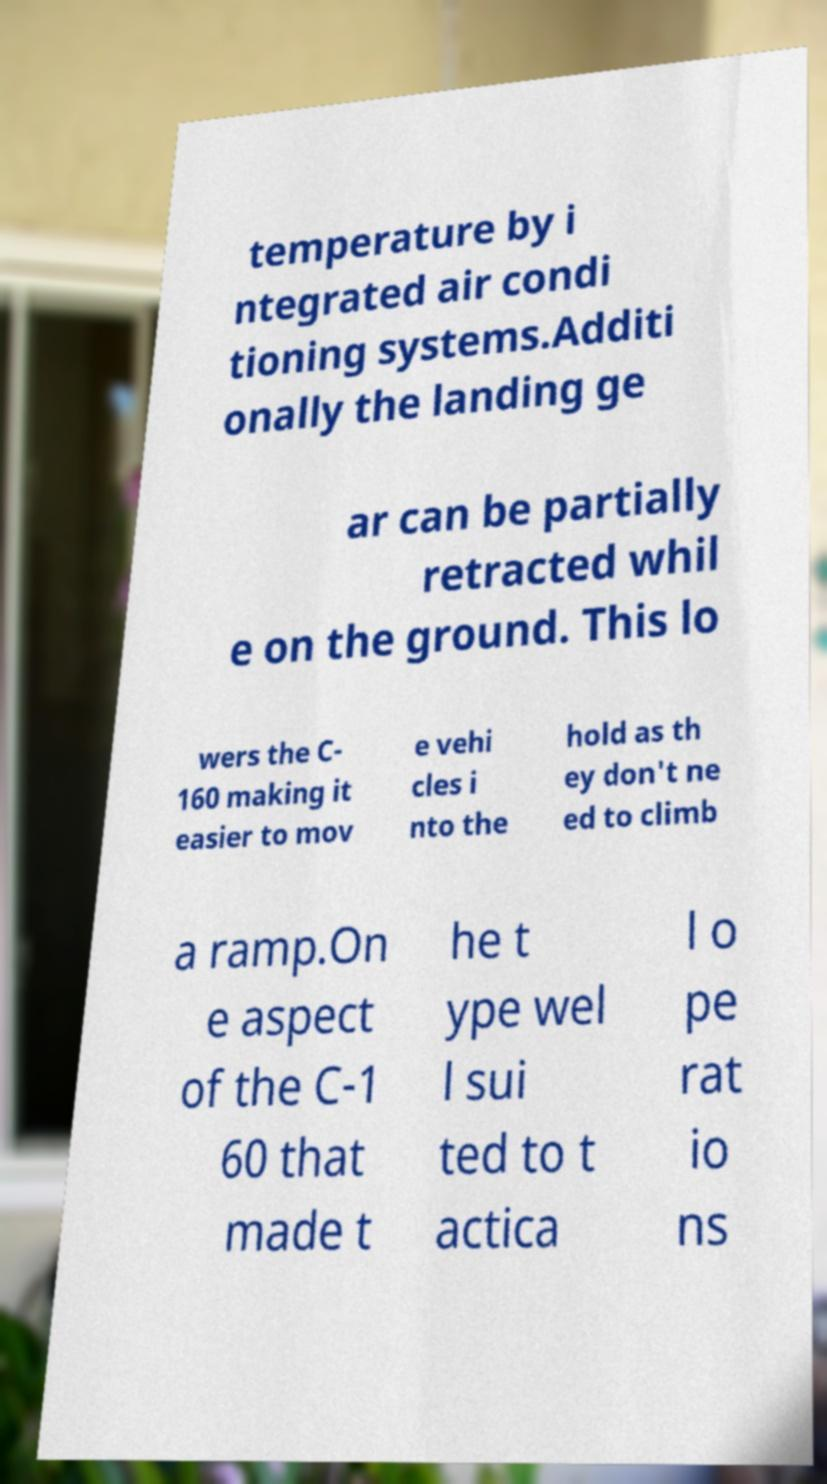For documentation purposes, I need the text within this image transcribed. Could you provide that? temperature by i ntegrated air condi tioning systems.Additi onally the landing ge ar can be partially retracted whil e on the ground. This lo wers the C- 160 making it easier to mov e vehi cles i nto the hold as th ey don't ne ed to climb a ramp.On e aspect of the C-1 60 that made t he t ype wel l sui ted to t actica l o pe rat io ns 